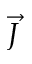<formula> <loc_0><loc_0><loc_500><loc_500>\vec { J }</formula> 